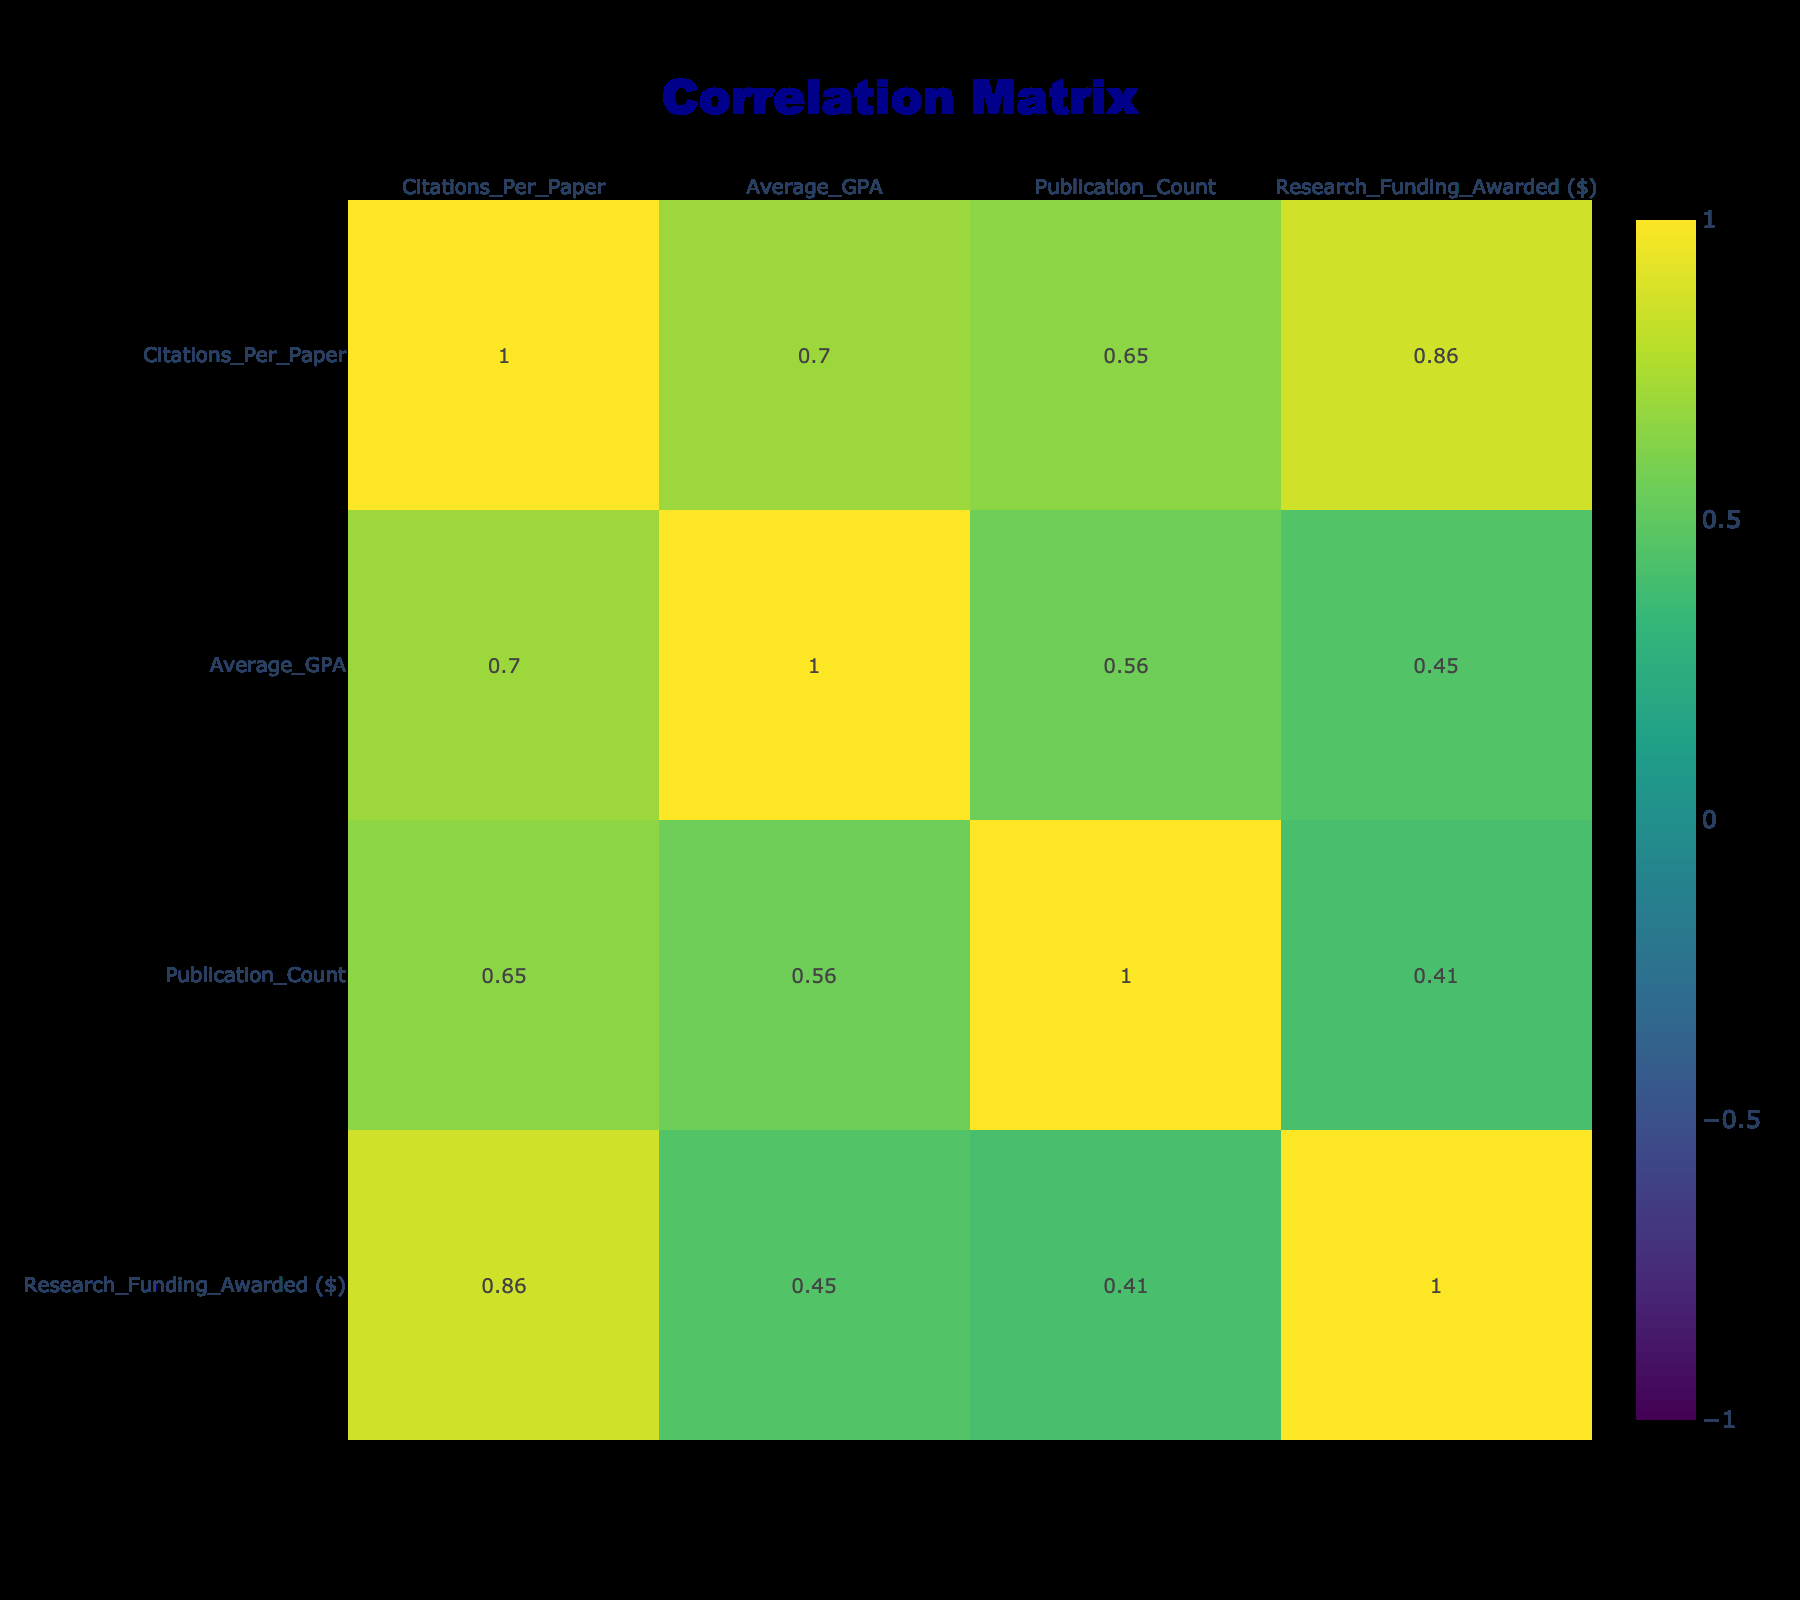What is the citation style used by the discipline with the highest average GPA? The table shows that Chemistry has the highest average GPA of 3.9. Looking at the row for Chemistry, the citation style used is ACS.
Answer: ACS Which discipline has the lowest publication count? In the table, the publication counts are listed for each discipline. By examining those counts, we find that Education has the lowest value, which is 5.
Answer: Education How many citations per paper are associated with the Engineering discipline? By checking the Engineering row in the table, we see that the number of citations per paper is 40.
Answer: 40 What is the average GPA for disciplines using APA citation style? The disciplines using APA are Biology, Psychology, Education, Sociology, and Business. Their average GPAs are 3.5, 3.8, 3.1, 3.5, and 3.2 respectively, giving a sum of 15.1. Dividing by the number of disciplines (5), the average GPA is 15.1/5 = 3.02.
Answer: 3.02 Is the total research funding awarded to disciplines using MLA greater than that awarded to those using Chicago? The total research funding for MLA (20,000) and Chicago (50,000) is calculated by comparing these values. MLA has less ($20,000 < $50,000), so the answer is no.
Answer: No What is the difference in citations per paper between the discipline with the highest and the lowest citations? The highest citations are from Chemistry (55) and the lowest are from Literature (30). The difference is calculated as 55 - 30 = 25.
Answer: 25 Which discipline has more citations per paper: Sociology or Education? Sociology has 25 citations per paper, while Education has 20. We compare these two values to determine that Sociology has more citations.
Answer: Sociology What is the total research funding awarded across all disciplines in the table? The funding values for each discipline are summed up: 150,000 + 50,000 + 200,000 + 300,000 + 20,000 + 250,000 + 40,000 + 350,000 + 60,000 + 100,000 = 1,520,000.
Answer: 1,520,000 What is the average number of citations per paper across all disciplines? The citation values for all disciplines are collected: 45, 32, 50, 40, 30, 55, 20, 65, 25, 35. Summing these values gives 45 + 32 + 50 + 40 + 30 + 55 + 20 + 65 + 25 + 35 =  427. Dividing by the number of disciplines (10) gives us an average of 427/10 = 42.7.
Answer: 42.7 